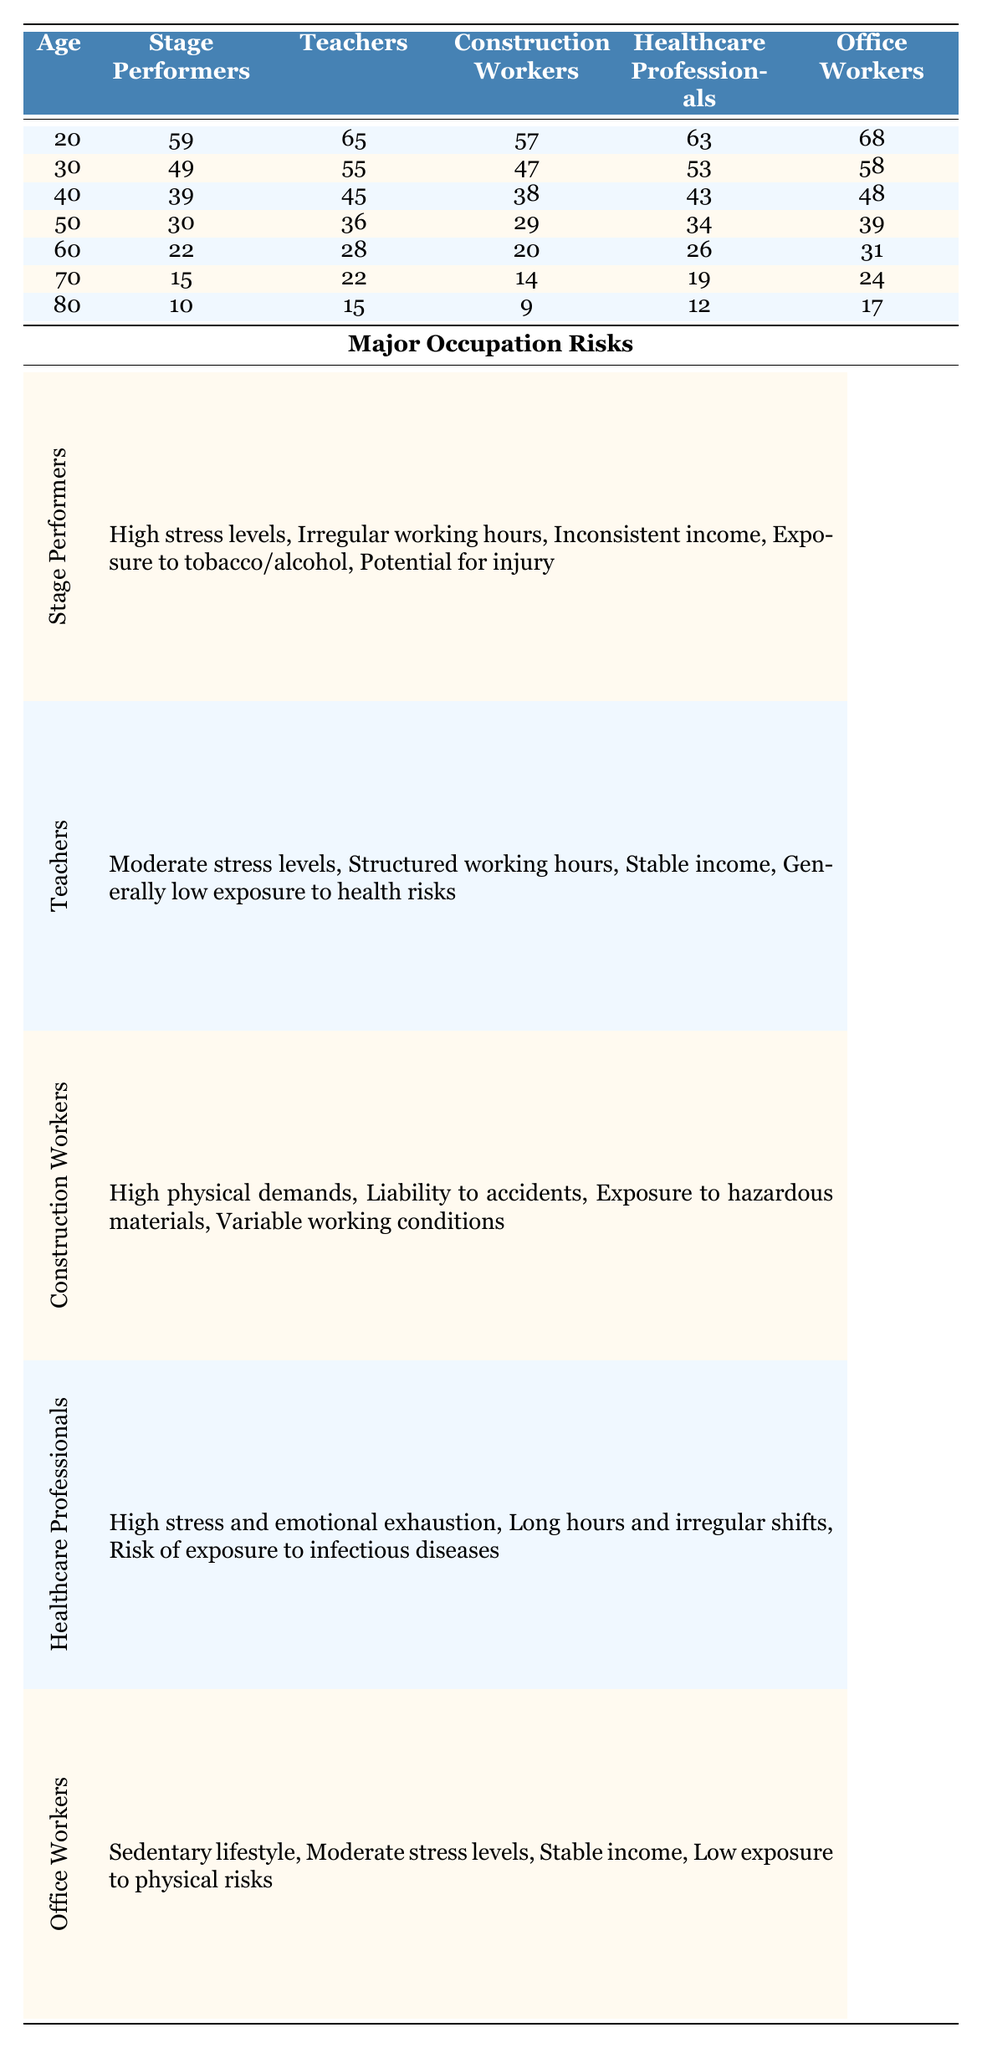what is the expected number of years lived by stage performers at age 50? According to the table, at age 50, stage performers are expected to live 30 more years.
Answer: 30 how many more years are expected to be lived by teachers than stage performers at age 40? At age 40, teachers are expected to live 45 years, while stage performers are expected to live 39 years. The difference is 45 - 39 = 6 years.
Answer: 6 is the expected number of years lived by office workers at age 70 greater than that of healthcare professionals? At age 70, office workers are expected to live 24 years, while healthcare professionals are expected to live 19 years. Since 24 is greater than 19, the statement is true.
Answer: Yes what is the average expected years lived by construction workers from age 20 to age 60? The expected years lived by construction workers at ages 20, 30, 40, 50, and 60 are 57, 47, 38, 29, and 20 respectively. The sum is 57 + 47 + 38 + 29 + 20 = 191. There are 5 data points, so the average is 191/5 = 38.2.
Answer: 38.2 how does the expected lifespan of stage performers at age 30 compare to that of healthcare professionals at age 60? At age 30, stage performers are expected to live 49 years, while healthcare professionals at age 60 are expected to live 26 years. Since 49 is greater than 26, stage performers have a higher expected lifespan at that age.
Answer: Stage performers have a higher lifespan 